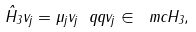Convert formula to latex. <formula><loc_0><loc_0><loc_500><loc_500>\hat { H } _ { 3 } v _ { j } = \mu _ { j } v _ { j } \ q q v _ { j } \in \ m c H _ { 3 } ,</formula> 